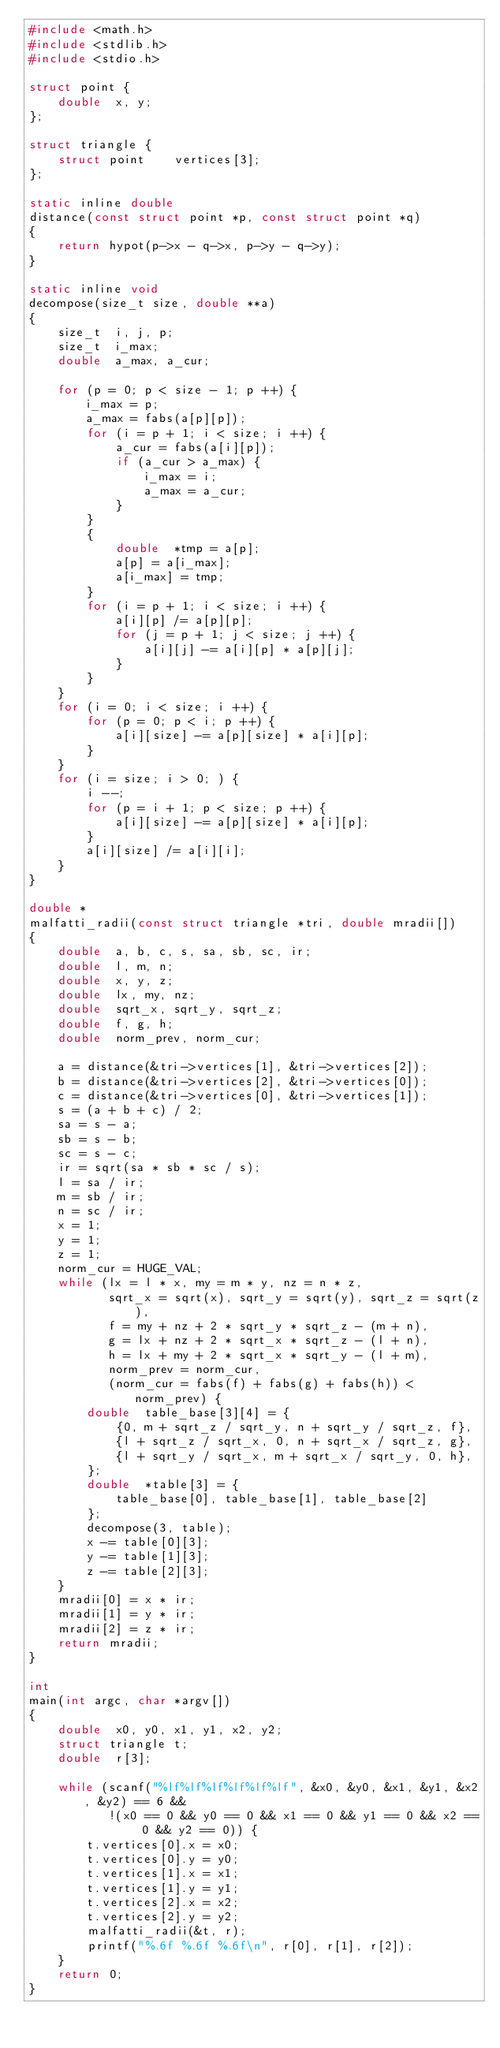Convert code to text. <code><loc_0><loc_0><loc_500><loc_500><_C_>#include <math.h>
#include <stdlib.h>
#include <stdio.h>

struct point {
	double	x, y;
};

struct triangle {
	struct point	vertices[3];
};

static inline double
distance(const struct point *p, const struct point *q)
{
	return hypot(p->x - q->x, p->y - q->y);
}

static inline void
decompose(size_t size, double **a)
{
	size_t	i, j, p;
	size_t	i_max;
	double	a_max, a_cur;

	for (p = 0; p < size - 1; p ++) {
		i_max = p;
		a_max = fabs(a[p][p]);
		for (i = p + 1; i < size; i ++) {
			a_cur = fabs(a[i][p]);
			if (a_cur > a_max) {
				i_max = i;
				a_max = a_cur;
			}
		}
		{
			double	*tmp = a[p];
			a[p] = a[i_max];
			a[i_max] = tmp;
		}
		for (i = p + 1; i < size; i ++) {
			a[i][p] /= a[p][p];
			for (j = p + 1; j < size; j ++) {
				a[i][j] -= a[i][p] * a[p][j];
			}
		}
	}
	for (i = 0; i < size; i ++) {
		for (p = 0; p < i; p ++) {
			a[i][size] -= a[p][size] * a[i][p];
		}
	}
	for (i = size; i > 0; ) {
		i --;
		for (p = i + 1; p < size; p ++) {
			a[i][size] -= a[p][size] * a[i][p];
		}
		a[i][size] /= a[i][i];
	}
}

double *
malfatti_radii(const struct triangle *tri, double mradii[])
{
	double	a, b, c, s, sa, sb, sc, ir;
	double	l, m, n;
	double	x, y, z;
	double	lx, my, nz;
	double	sqrt_x, sqrt_y, sqrt_z;
	double	f, g, h;
	double	norm_prev, norm_cur;

	a = distance(&tri->vertices[1], &tri->vertices[2]);
	b = distance(&tri->vertices[2], &tri->vertices[0]);
	c = distance(&tri->vertices[0], &tri->vertices[1]);
	s = (a + b + c) / 2;
	sa = s - a;
	sb = s - b;
	sc = s - c;
	ir = sqrt(sa * sb * sc / s);
	l = sa / ir;
	m = sb / ir;
	n = sc / ir;
	x = 1;
	y = 1;
	z = 1;
	norm_cur = HUGE_VAL;
	while (lx = l * x, my = m * y, nz = n * z,
	       sqrt_x = sqrt(x), sqrt_y = sqrt(y), sqrt_z = sqrt(z),
	       f = my + nz + 2 * sqrt_y * sqrt_z - (m + n),
	       g = lx + nz + 2 * sqrt_x * sqrt_z - (l + n),
	       h = lx + my + 2 * sqrt_x * sqrt_y - (l + m),
	       norm_prev = norm_cur,
	       (norm_cur = fabs(f) + fabs(g) + fabs(h)) < norm_prev) {
		double	table_base[3][4] = {
			{0, m + sqrt_z / sqrt_y, n + sqrt_y / sqrt_z, f},
			{l + sqrt_z / sqrt_x, 0, n + sqrt_x / sqrt_z, g},
			{l + sqrt_y / sqrt_x, m + sqrt_x / sqrt_y, 0, h},
		};
		double	*table[3] = {
			table_base[0], table_base[1], table_base[2]
		};
		decompose(3, table);
		x -= table[0][3];
		y -= table[1][3];
		z -= table[2][3];
	}
	mradii[0] = x * ir;
	mradii[1] = y * ir;
	mradii[2] = z * ir;
	return mradii;
}

int
main(int argc, char *argv[])
{
	double	x0, y0, x1, y1, x2, y2;
	struct triangle	t;
	double	r[3];

	while (scanf("%lf%lf%lf%lf%lf%lf", &x0, &y0, &x1, &y1, &x2, &y2) == 6 &&
	       !(x0 == 0 && y0 == 0 && x1 == 0 && y1 == 0 && x2 == 0 && y2 == 0)) {
		t.vertices[0].x = x0;
		t.vertices[0].y = y0;
		t.vertices[1].x = x1;
		t.vertices[1].y = y1;
		t.vertices[2].x = x2;
		t.vertices[2].y = y2;
		malfatti_radii(&t, r);
		printf("%.6f %.6f %.6f\n", r[0], r[1], r[2]);
	}
	return 0;
}
</code> 